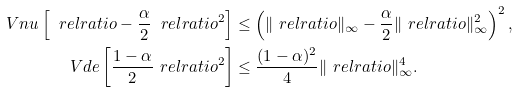<formula> <loc_0><loc_0><loc_500><loc_500>\ V n u \left [ \ r e l r a t i o - \frac { \alpha } { 2 } \ r e l r a t i o ^ { 2 } \right ] & \leq \left ( \| \ r e l r a t i o \| _ { \infty } - \frac { \alpha } { 2 } \| \ r e l r a t i o \| _ { \infty } ^ { 2 } \right ) ^ { 2 } , \\ \ V d e \left [ \frac { 1 - \alpha } { 2 } \ r e l r a t i o ^ { 2 } \right ] & \leq \frac { ( 1 - \alpha ) ^ { 2 } } { 4 } \| \ r e l r a t i o \| _ { \infty } ^ { 4 } .</formula> 